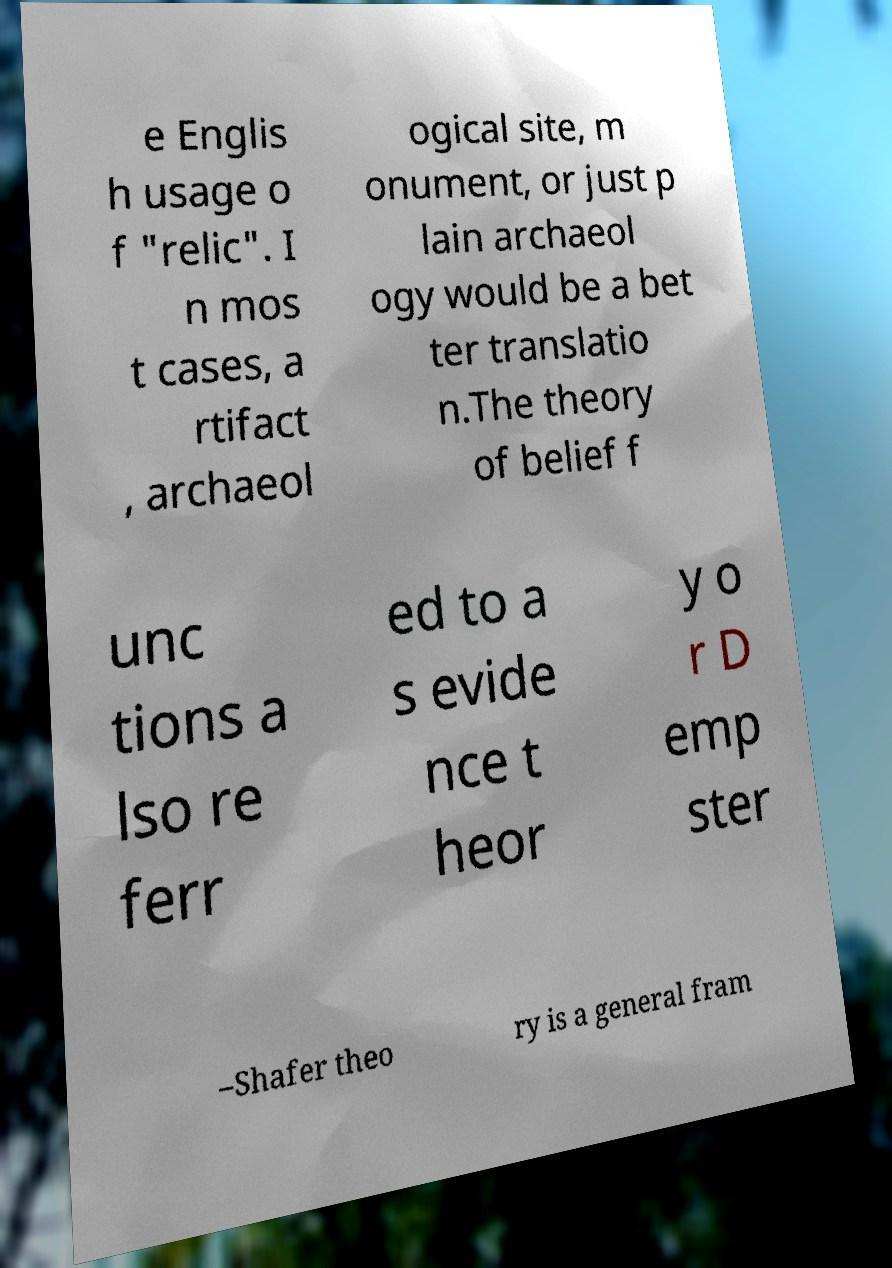Could you assist in decoding the text presented in this image and type it out clearly? e Englis h usage o f "relic". I n mos t cases, a rtifact , archaeol ogical site, m onument, or just p lain archaeol ogy would be a bet ter translatio n.The theory of belief f unc tions a lso re ferr ed to a s evide nce t heor y o r D emp ster –Shafer theo ry is a general fram 